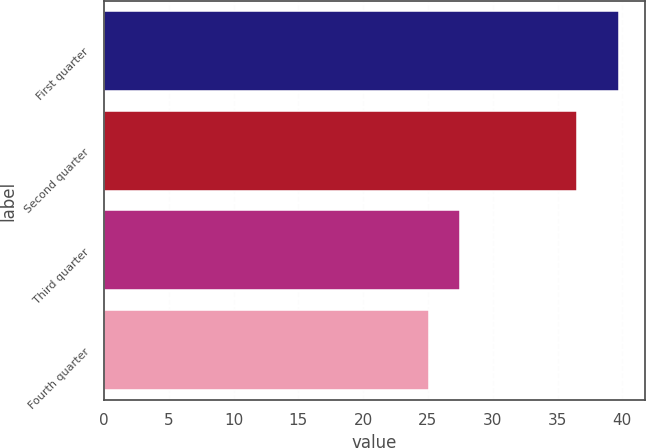<chart> <loc_0><loc_0><loc_500><loc_500><bar_chart><fcel>First quarter<fcel>Second quarter<fcel>Third quarter<fcel>Fourth quarter<nl><fcel>39.77<fcel>36.51<fcel>27.44<fcel>25.06<nl></chart> 